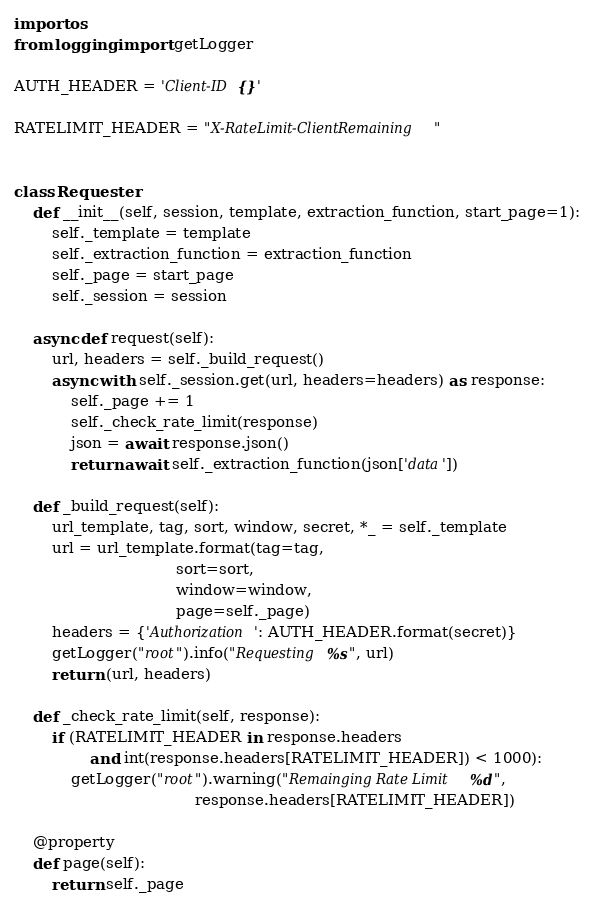Convert code to text. <code><loc_0><loc_0><loc_500><loc_500><_Python_>import os
from logging import getLogger

AUTH_HEADER = 'Client-ID {}'

RATELIMIT_HEADER = "X-RateLimit-ClientRemaining"


class Requester:
    def __init__(self, session, template, extraction_function, start_page=1):
        self._template = template
        self._extraction_function = extraction_function
        self._page = start_page
        self._session = session

    async def request(self):
        url, headers = self._build_request()
        async with self._session.get(url, headers=headers) as response:
            self._page += 1
            self._check_rate_limit(response)
            json = await response.json()
            return await self._extraction_function(json['data'])

    def _build_request(self):
        url_template, tag, sort, window, secret, *_ = self._template
        url = url_template.format(tag=tag,
                                  sort=sort,
                                  window=window,
                                  page=self._page)
        headers = {'Authorization': AUTH_HEADER.format(secret)}
        getLogger("root").info("Requesting %s", url)
        return (url, headers)

    def _check_rate_limit(self, response):
        if (RATELIMIT_HEADER in response.headers
                and int(response.headers[RATELIMIT_HEADER]) < 1000):
            getLogger("root").warning("Remainging Rate Limit %d",
                                      response.headers[RATELIMIT_HEADER])

    @property
    def page(self):
        return self._page
</code> 